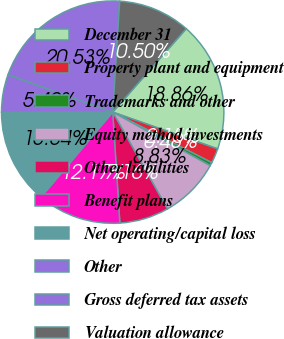Convert chart. <chart><loc_0><loc_0><loc_500><loc_500><pie_chart><fcel>December 31<fcel>Property plant and equipment<fcel>Trademarks and other<fcel>Equity method investments<fcel>Other liabilities<fcel>Benefit plans<fcel>Net operating/capital loss<fcel>Other<fcel>Gross deferred tax assets<fcel>Valuation allowance<nl><fcel>18.86%<fcel>2.15%<fcel>0.48%<fcel>8.83%<fcel>7.16%<fcel>12.17%<fcel>13.84%<fcel>5.49%<fcel>20.53%<fcel>10.5%<nl></chart> 